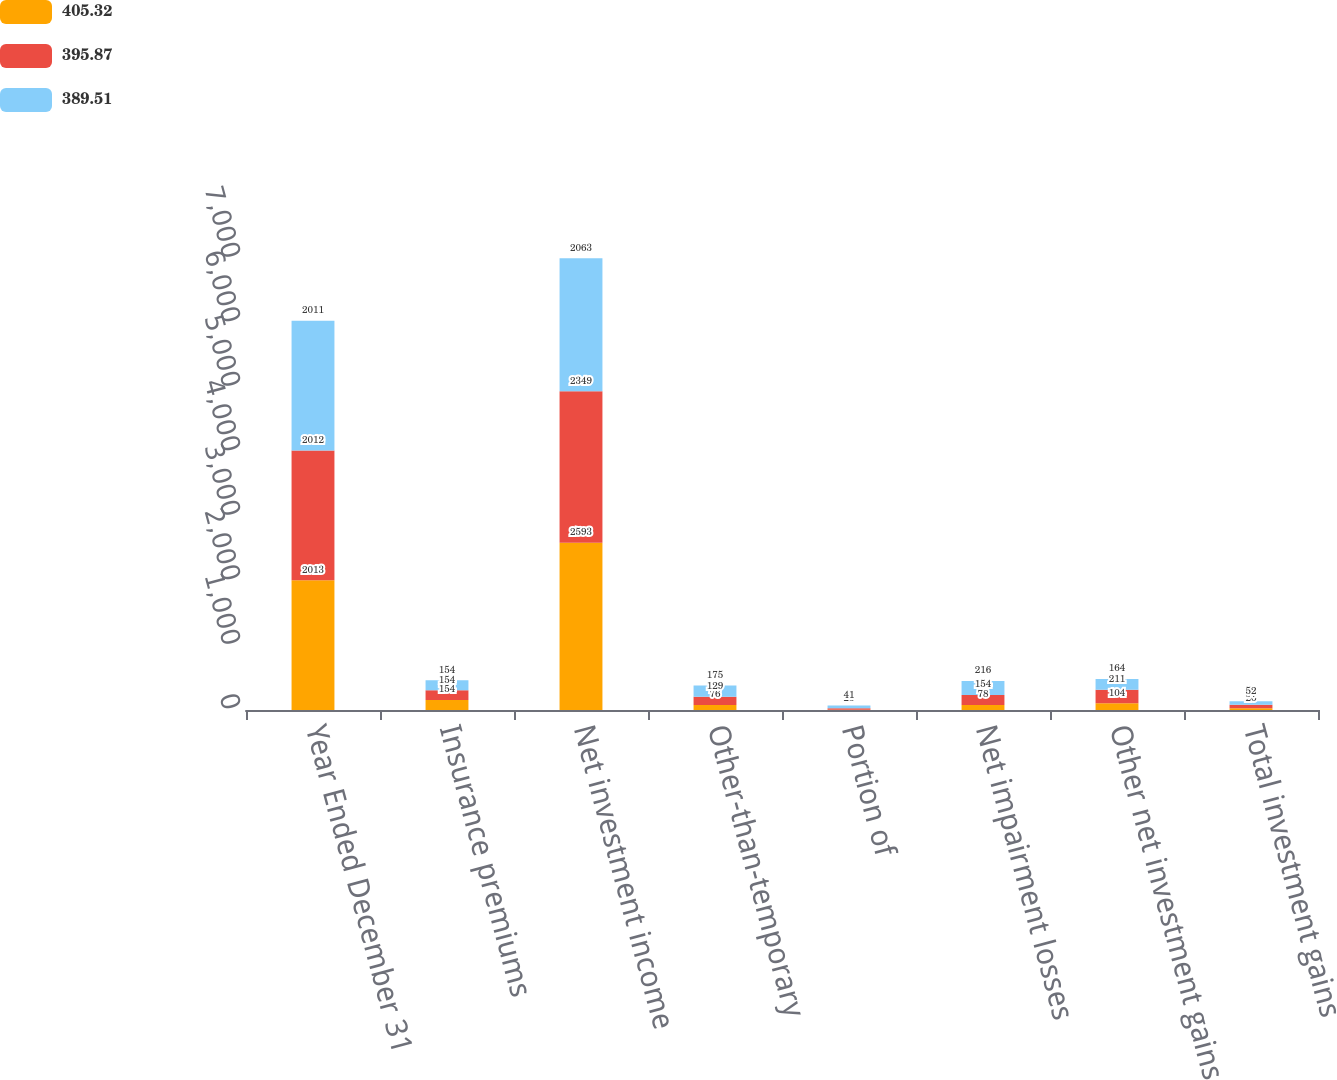Convert chart to OTSL. <chart><loc_0><loc_0><loc_500><loc_500><stacked_bar_chart><ecel><fcel>Year Ended December 31<fcel>Insurance premiums<fcel>Net investment income<fcel>Other-than-temporary<fcel>Portion of<fcel>Net impairment losses<fcel>Other net investment gains<fcel>Total investment gains<nl><fcel>405.32<fcel>2013<fcel>154<fcel>2593<fcel>76<fcel>2<fcel>78<fcel>104<fcel>26<nl><fcel>395.87<fcel>2012<fcel>154<fcel>2349<fcel>129<fcel>25<fcel>154<fcel>211<fcel>57<nl><fcel>389.51<fcel>2011<fcel>154<fcel>2063<fcel>175<fcel>41<fcel>216<fcel>164<fcel>52<nl></chart> 